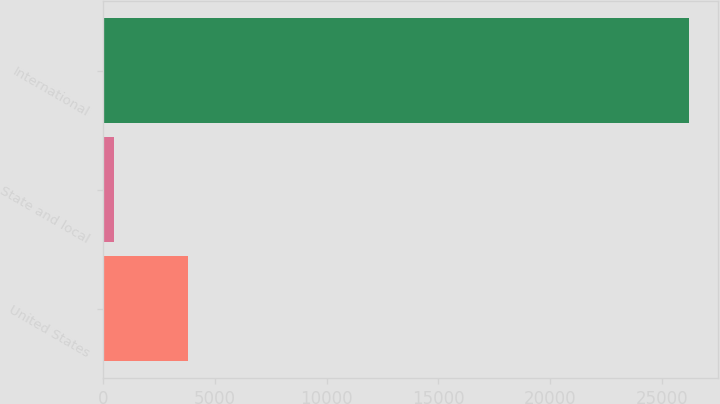Convert chart. <chart><loc_0><loc_0><loc_500><loc_500><bar_chart><fcel>United States<fcel>State and local<fcel>International<nl><fcel>3786<fcel>497<fcel>26198<nl></chart> 